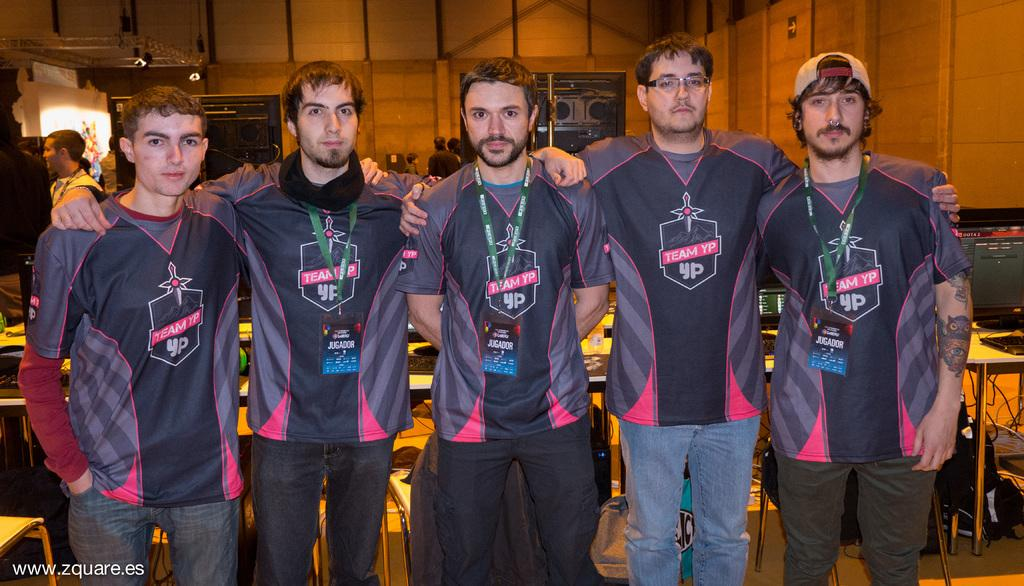What are the men in the image doing? The men in the image are standing on the floor. What can be seen in the background of the image? In the background, there are people standing on the floor, tables, desktops, cables, bags, and electric lights. How many types of objects can be seen in the background of the image? There are seven types of objects visible in the background of the image. What type of hill can be seen in the image? There is no hill present in the image. What color is the shirt worn by the man in the image? The provided facts do not mention any specific clothing worn by the men in the image. 